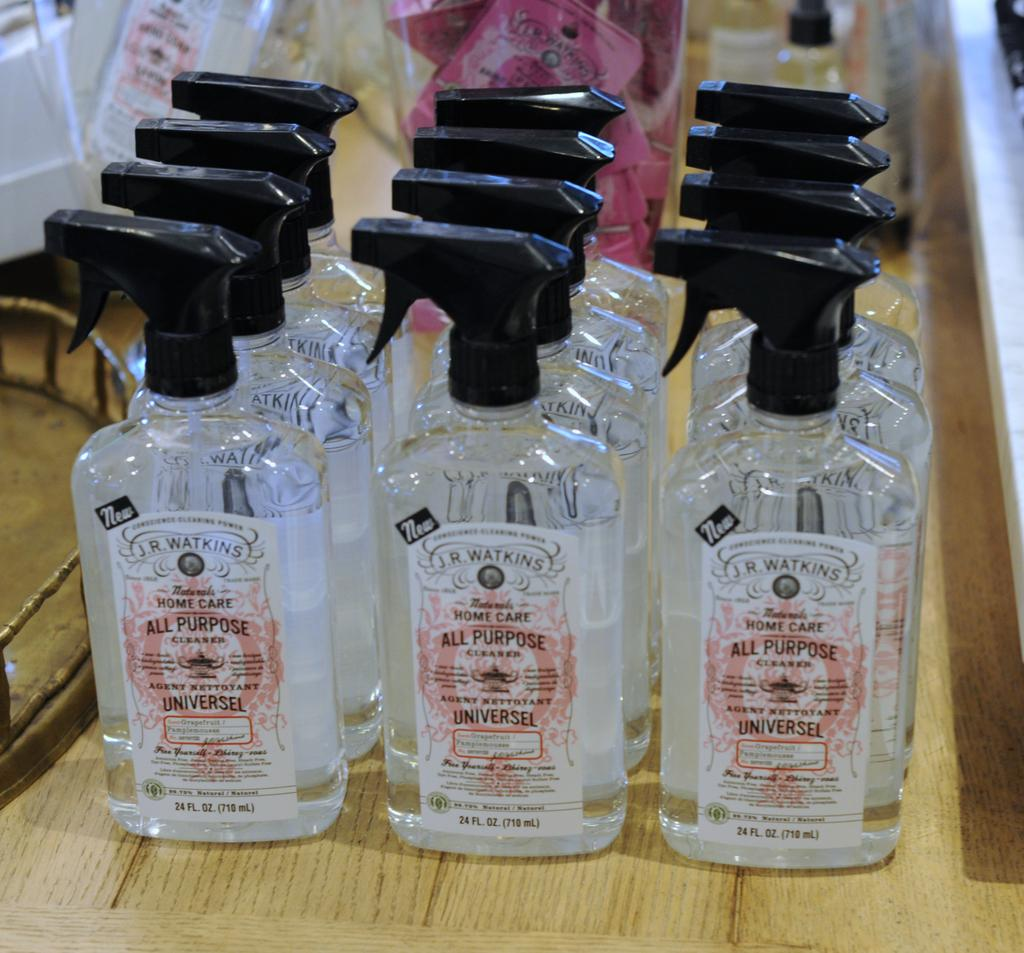<image>
Create a compact narrative representing the image presented. Several bottles of cleaning fluid with all purpose written on it 